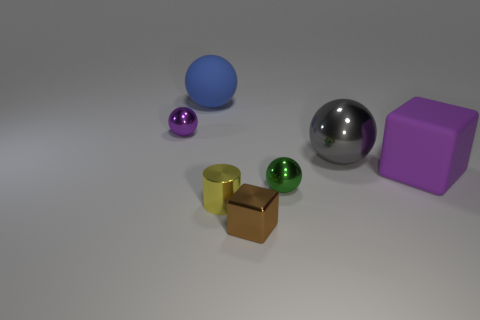How many brown blocks are there?
Your answer should be very brief. 1. Is there any other thing that has the same size as the yellow shiny thing?
Ensure brevity in your answer.  Yes. Is the brown cube made of the same material as the big gray sphere?
Offer a terse response. Yes. There is a metallic ball on the left side of the big blue thing; is it the same size as the rubber object right of the blue thing?
Provide a succinct answer. No. Is the number of brown metal cylinders less than the number of big things?
Your answer should be very brief. Yes. What number of metal things are either small green spheres or small blue spheres?
Your response must be concise. 1. Is there a rubber sphere that is in front of the metal object to the left of the big blue matte object?
Give a very brief answer. No. Does the sphere that is on the right side of the green metallic sphere have the same material as the brown block?
Provide a short and direct response. Yes. What number of other things are the same color as the large cube?
Your answer should be compact. 1. Do the big matte sphere and the rubber cube have the same color?
Keep it short and to the point. No. 